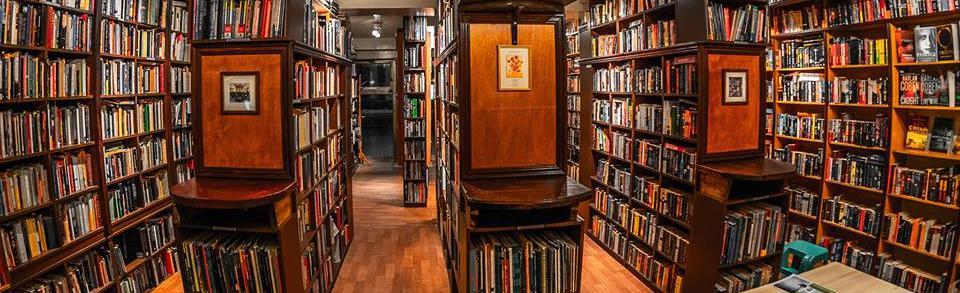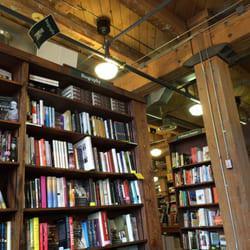The first image is the image on the left, the second image is the image on the right. For the images displayed, is the sentence "In the image on the right, there is at least one table that holds some books propped up on bookstands." factually correct? Answer yes or no. No. The first image is the image on the left, the second image is the image on the right. Evaluate the accuracy of this statement regarding the images: "In at least one image there is an empty bookstore  with table that has at least 30 books on it.". Is it true? Answer yes or no. No. 